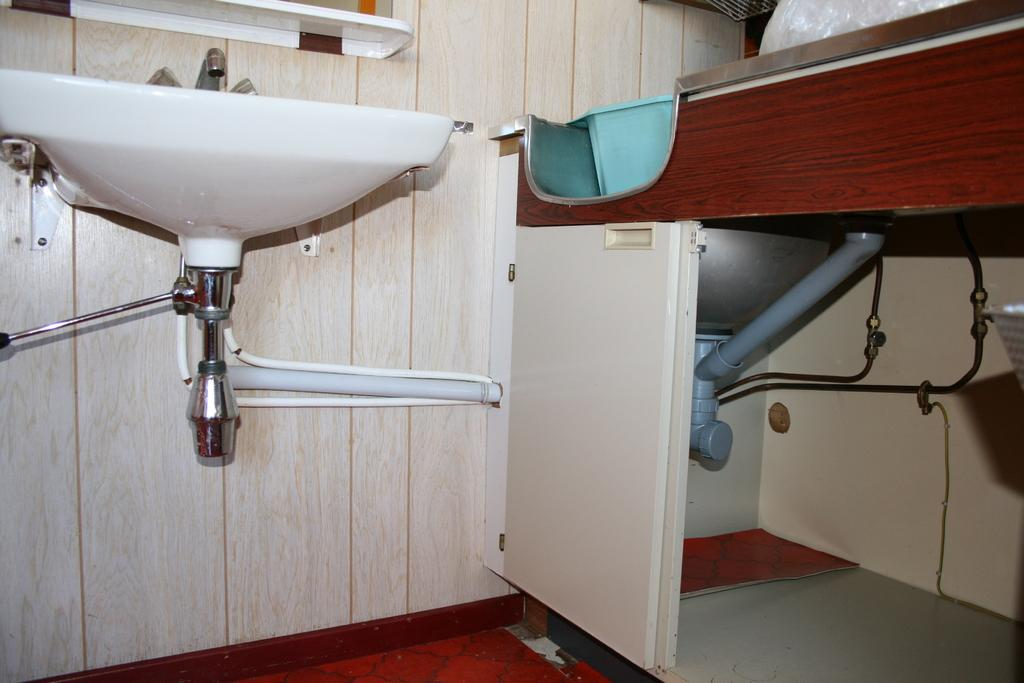What is the main fixture in the image? There is a wash basin in the image. What is attached to the wash basin? There is a tap in the image. What type of furniture is present in the image? There is a wooden cupboard in the image. What can be seen on the wooden cupboard? The wooden cupboard has pipes visible. What type of door is in the image? There is a wooden door in the image. What part of the room can be seen in the image? The floor is visible in the image. What can be used for personal grooming in the image? There is a mirror in the image. What type of treatment is the stranger receiving in the image? There is no stranger present in the image, and therefore no treatment can be observed. 